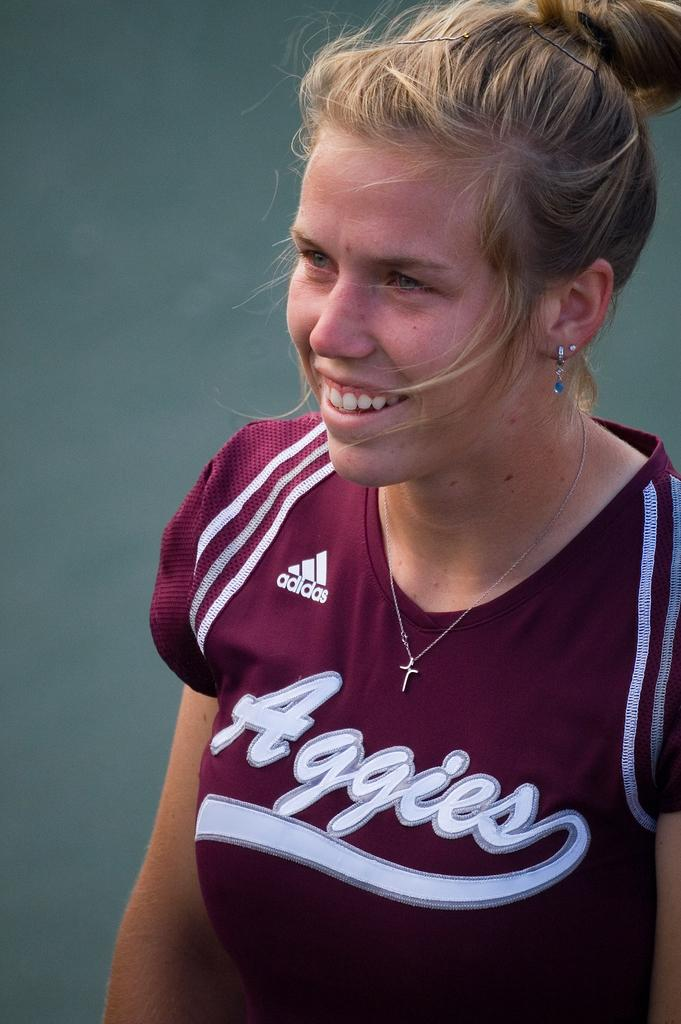Provide a one-sentence caption for the provided image. A blonde female smiling with an purple Aggies team shirt. 